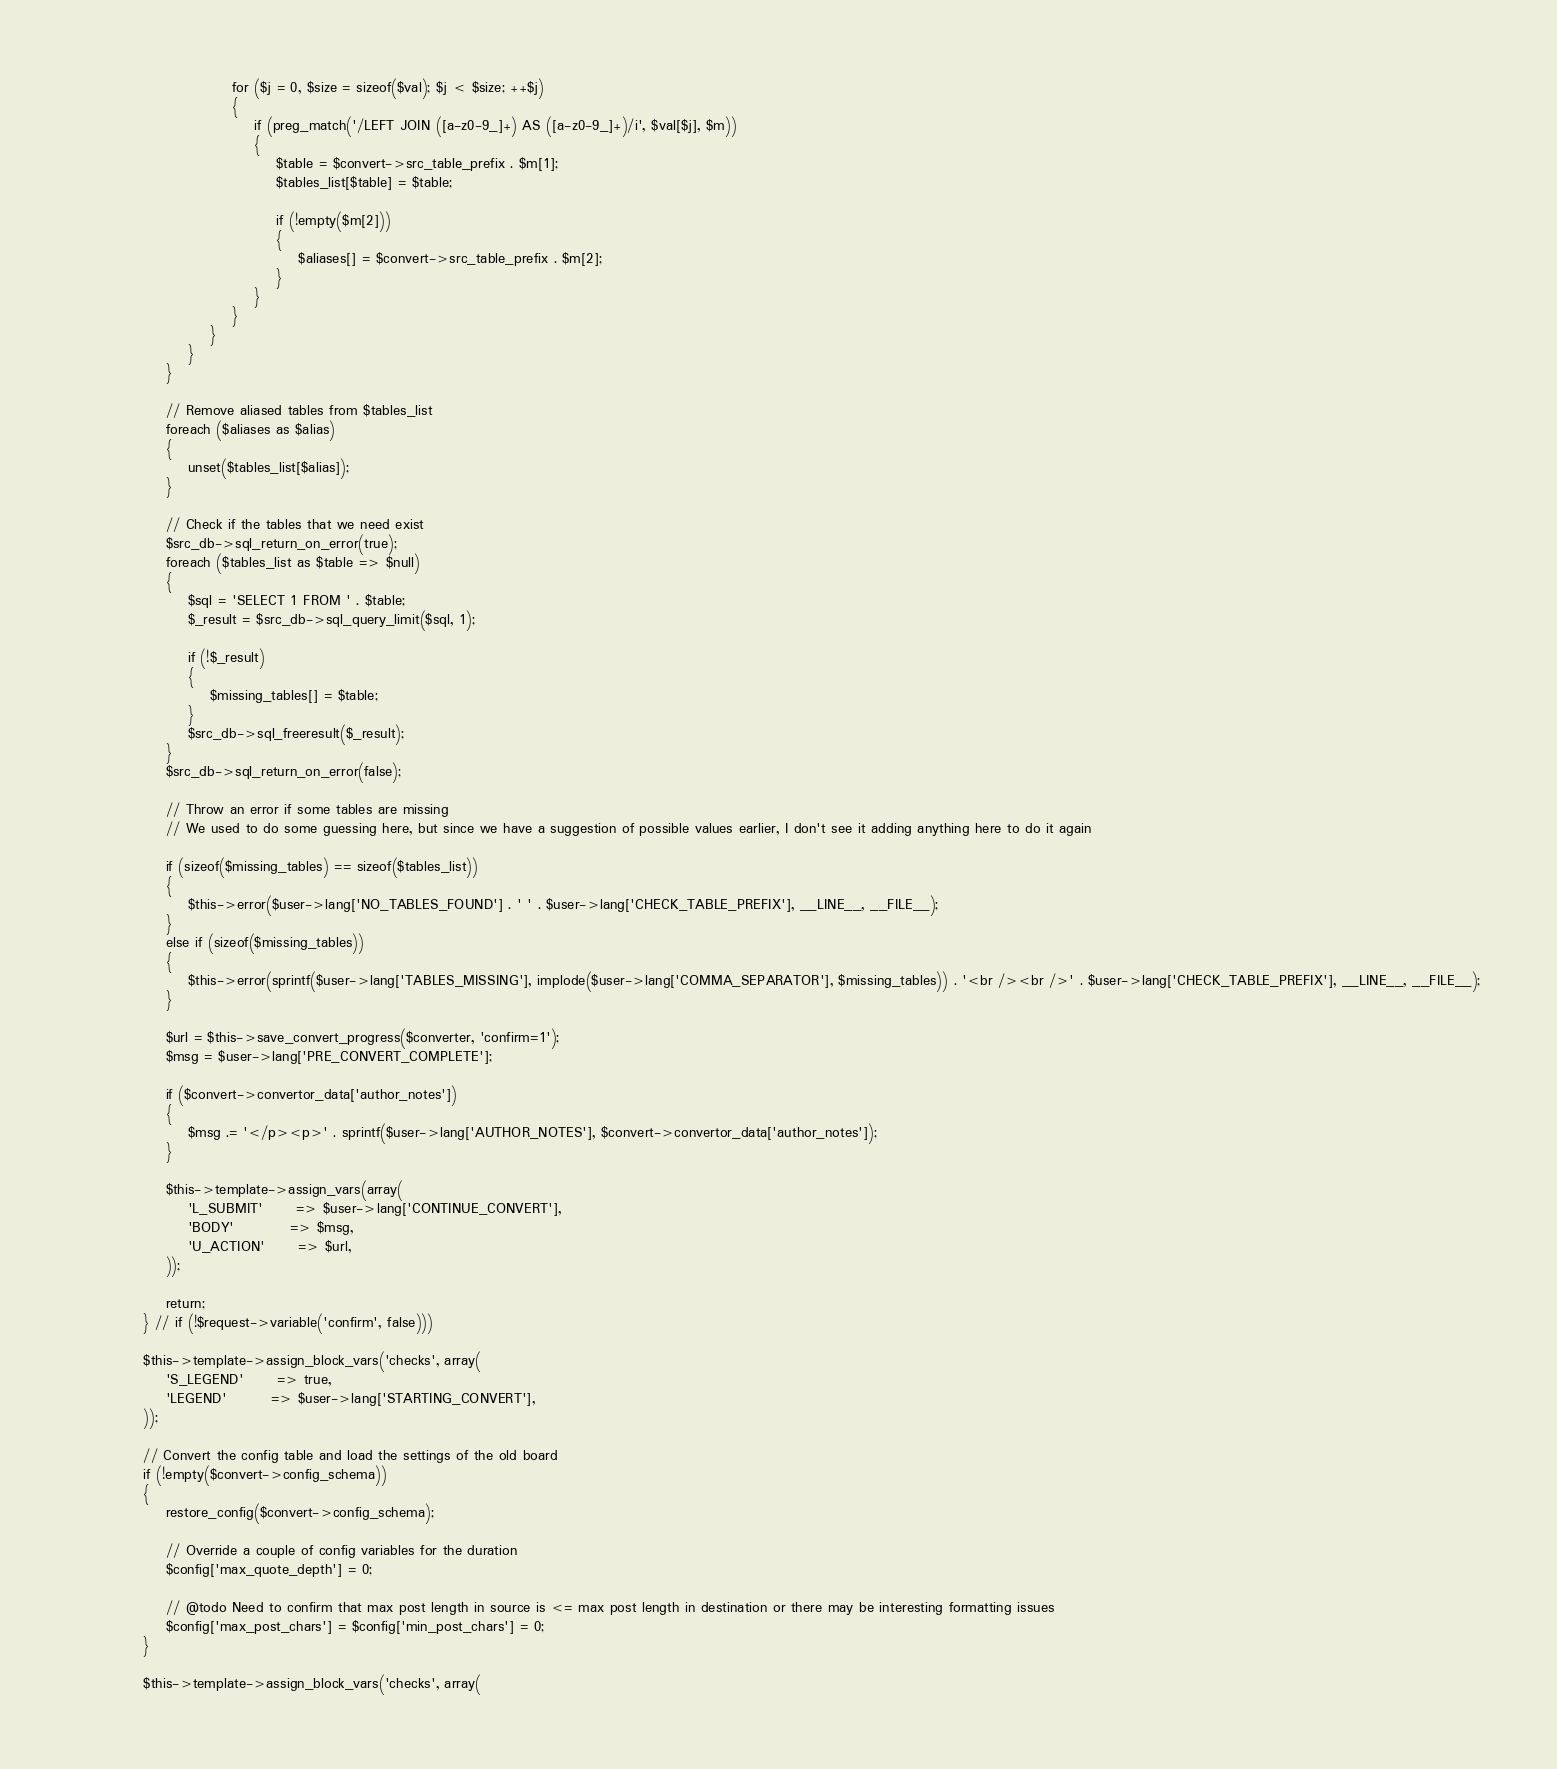<code> <loc_0><loc_0><loc_500><loc_500><_PHP_>
							for ($j = 0, $size = sizeof($val); $j < $size; ++$j)
							{
								if (preg_match('/LEFT JOIN ([a-z0-9_]+) AS ([a-z0-9_]+)/i', $val[$j], $m))
								{
									$table = $convert->src_table_prefix . $m[1];
									$tables_list[$table] = $table;

									if (!empty($m[2]))
									{
										$aliases[] = $convert->src_table_prefix . $m[2];
									}
								}
							}
						}
					}
				}

				// Remove aliased tables from $tables_list
				foreach ($aliases as $alias)
				{
					unset($tables_list[$alias]);
				}

				// Check if the tables that we need exist
				$src_db->sql_return_on_error(true);
				foreach ($tables_list as $table => $null)
				{
					$sql = 'SELECT 1 FROM ' . $table;
					$_result = $src_db->sql_query_limit($sql, 1);

					if (!$_result)
					{
						$missing_tables[] = $table;
					}
					$src_db->sql_freeresult($_result);
				}
				$src_db->sql_return_on_error(false);

				// Throw an error if some tables are missing
				// We used to do some guessing here, but since we have a suggestion of possible values earlier, I don't see it adding anything here to do it again

				if (sizeof($missing_tables) == sizeof($tables_list))
				{
					$this->error($user->lang['NO_TABLES_FOUND'] . ' ' . $user->lang['CHECK_TABLE_PREFIX'], __LINE__, __FILE__);
				}
				else if (sizeof($missing_tables))
				{
					$this->error(sprintf($user->lang['TABLES_MISSING'], implode($user->lang['COMMA_SEPARATOR'], $missing_tables)) . '<br /><br />' . $user->lang['CHECK_TABLE_PREFIX'], __LINE__, __FILE__);
				}

				$url = $this->save_convert_progress($converter, 'confirm=1');
				$msg = $user->lang['PRE_CONVERT_COMPLETE'];

				if ($convert->convertor_data['author_notes'])
				{
					$msg .= '</p><p>' . sprintf($user->lang['AUTHOR_NOTES'], $convert->convertor_data['author_notes']);
				}

				$this->template->assign_vars(array(
					'L_SUBMIT'		=> $user->lang['CONTINUE_CONVERT'],
					'BODY'			=> $msg,
					'U_ACTION'		=> $url,
				));

				return;
			} // if (!$request->variable('confirm', false)))

			$this->template->assign_block_vars('checks', array(
				'S_LEGEND'		=> true,
				'LEGEND'		=> $user->lang['STARTING_CONVERT'],
			));

			// Convert the config table and load the settings of the old board
			if (!empty($convert->config_schema))
			{
				restore_config($convert->config_schema);

				// Override a couple of config variables for the duration
				$config['max_quote_depth'] = 0;

				// @todo Need to confirm that max post length in source is <= max post length in destination or there may be interesting formatting issues
				$config['max_post_chars'] = $config['min_post_chars'] = 0;
			}

			$this->template->assign_block_vars('checks', array(</code> 